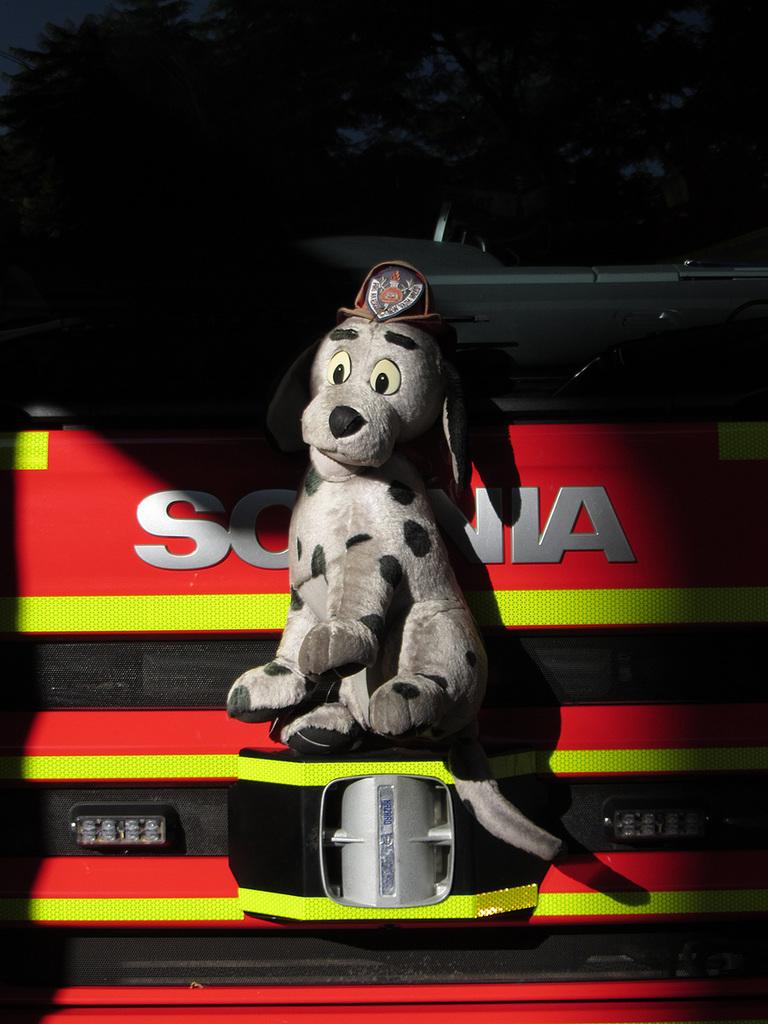What is the main subject of the image? There is a sculpture of a dog in the image. Are there any other objects or elements in the image besides the dog sculpture? Yes, there are other objects in the image. Can you describe what is written on a red color surface in the image? Unfortunately, the facts provided do not give any information about what is written on the red surface. What type of wool is being used to create the map in the image? There is no map or wool present in the image. 